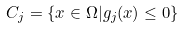Convert formula to latex. <formula><loc_0><loc_0><loc_500><loc_500>C _ { j } = \{ x \in \Omega | g _ { j } ( x ) \leq 0 \}</formula> 